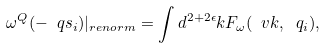Convert formula to latex. <formula><loc_0><loc_0><loc_500><loc_500>\omega ^ { Q } ( - \ q s _ { i } ) | _ { r e n o r m } = \int d ^ { 2 + 2 \epsilon } k F _ { \omega } ( \ v k , \ q _ { i } ) ,</formula> 